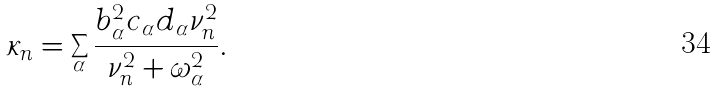<formula> <loc_0><loc_0><loc_500><loc_500>\kappa _ { n } = \sum _ { \alpha } \frac { b _ { \alpha } ^ { 2 } c _ { \alpha } d _ { \alpha } \nu _ { n } ^ { 2 } } { \nu _ { n } ^ { 2 } + \omega _ { \alpha } ^ { 2 } } .</formula> 